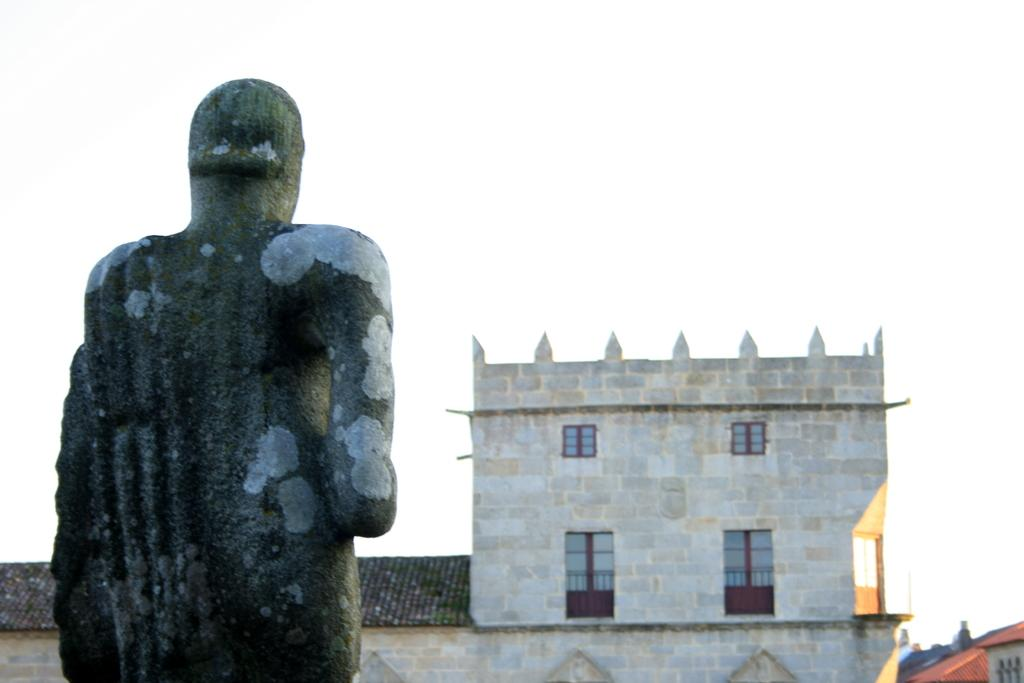What is the main subject in the foreground of the image? There is a statue in the foreground of the image. What can be seen in the background of the image? There is a building in the background of the image. What is visible at the top of the image? The sky is visible at the top of the image. What color is the crayon used to draw the statue in the image? There is no crayon present in the image, and the statue is not a drawing. 